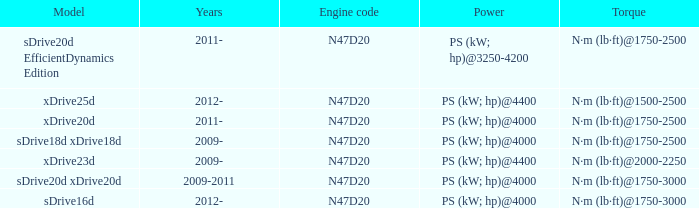What model is the n·m (lb·ft)@1500-2500 torque? Xdrive25d. 